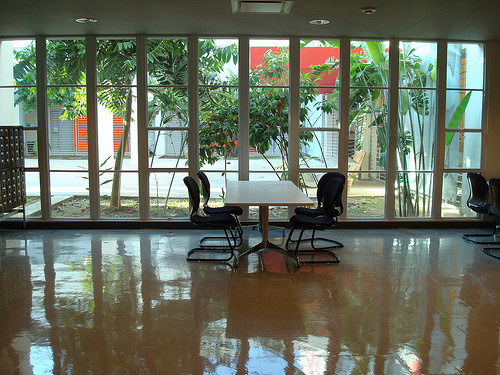<image>
Is there a tree above the table? No. The tree is not positioned above the table. The vertical arrangement shows a different relationship. 